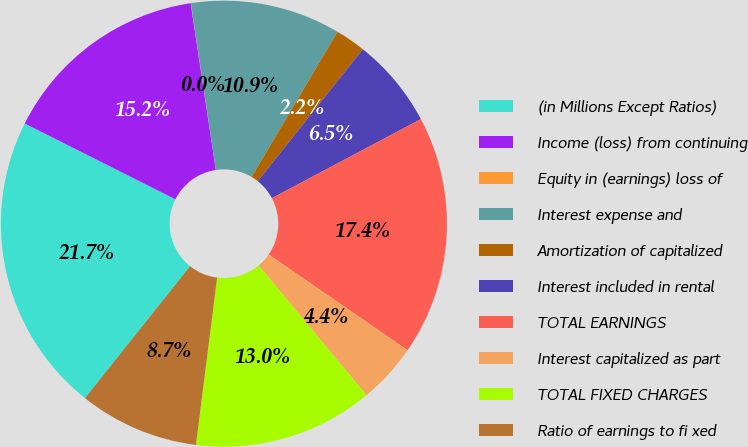Convert chart. <chart><loc_0><loc_0><loc_500><loc_500><pie_chart><fcel>(in Millions Except Ratios)<fcel>Income (loss) from continuing<fcel>Equity in (earnings) loss of<fcel>Interest expense and<fcel>Amortization of capitalized<fcel>Interest included in rental<fcel>TOTAL EARNINGS<fcel>Interest capitalized as part<fcel>TOTAL FIXED CHARGES<fcel>Ratio of earnings to fi xed<nl><fcel>21.71%<fcel>15.2%<fcel>0.02%<fcel>10.87%<fcel>2.19%<fcel>6.53%<fcel>17.37%<fcel>4.36%<fcel>13.04%<fcel>8.7%<nl></chart> 